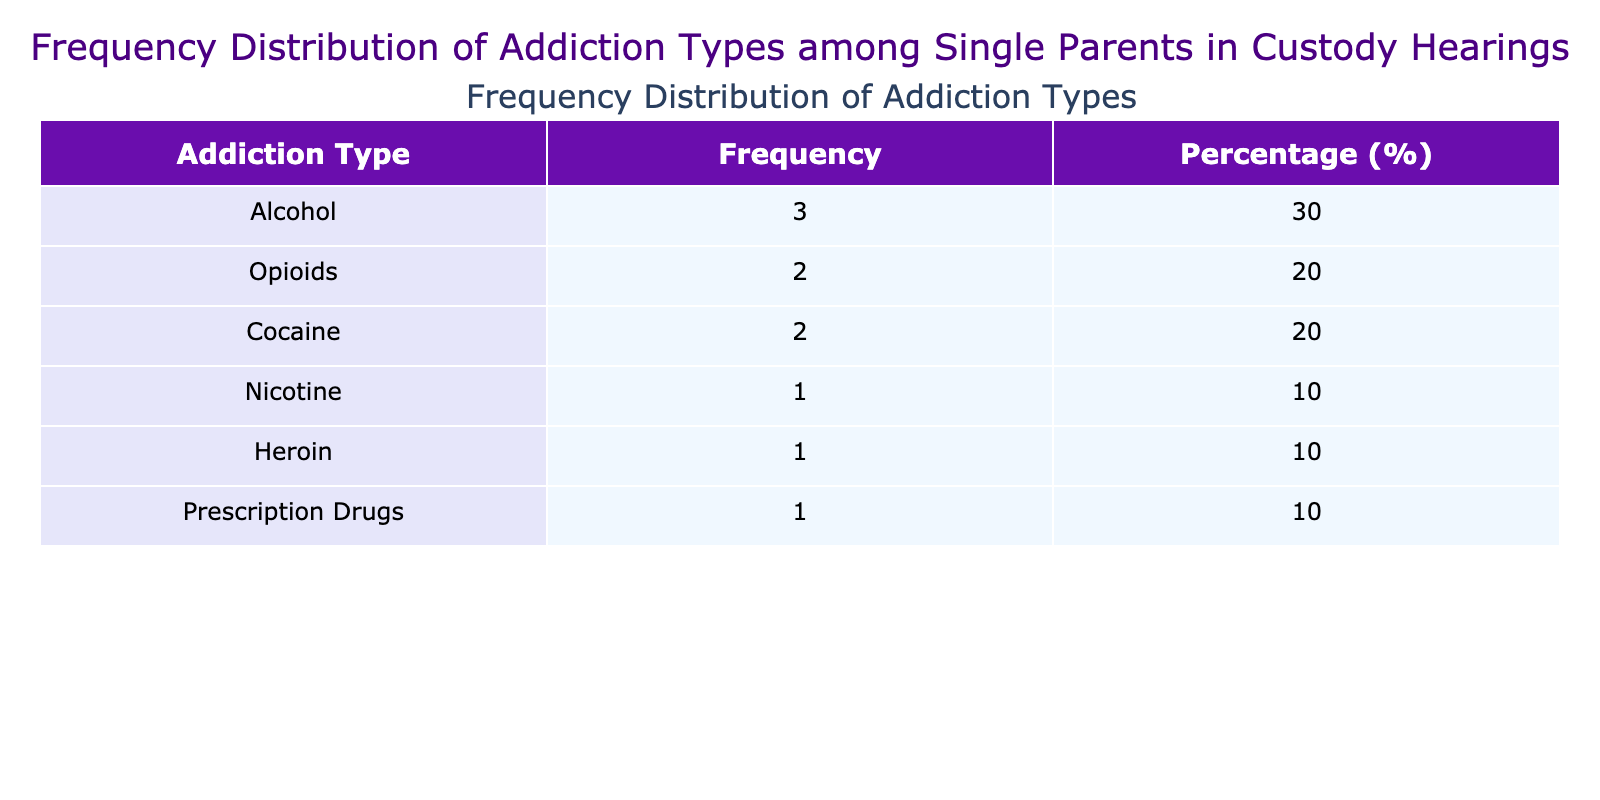What is the frequency of custody hearing outcomes for parents dealing with Opioids? Looking at the table, we see two entries related to Opioids. Emily Johnson had a custody hearing outcome of Denied, and Ashley Anderson had a outcome of Granted. Therefore, the frequency is 1 Granted and 1 Denied.
Answer: 1 Granted, 1 Denied Which addiction type had the highest frequency in the table? By examining the frequency column in the table, we note that Alcohol appears three times (John Smith, Michael Green, Daniel Wilson), which is more than any other addiction type listed.
Answer: Alcohol Is there a parent whose custody hearing is still pending? Reviewing the table, we find that Sarah Davis is the only parent with a custody hearing outcome listed as Pending.
Answer: Yes What percentage of parents with Nicotine addiction had their custody hearing outcome granted? In the table, there is only one parent with Nicotine, David Brown, and his outcome is Granted. Since there is one occurrence and it is granted, the percentage is calculated by (1/1)*100 = 100%.
Answer: 100% How many parents had their custody hearings granted between 2021 and 2023? To determine this, we can sum up the outcomes from the relevant years, which are 2021 (none granted), 2022 (granted: Michael Green, Ashley Anderson), and 2023 (granted: John Smith, David Brown, Jessica Martinez) giving 1 + 2 + 3 = 5 total parents who had their hearing outcomes granted.
Answer: 5 